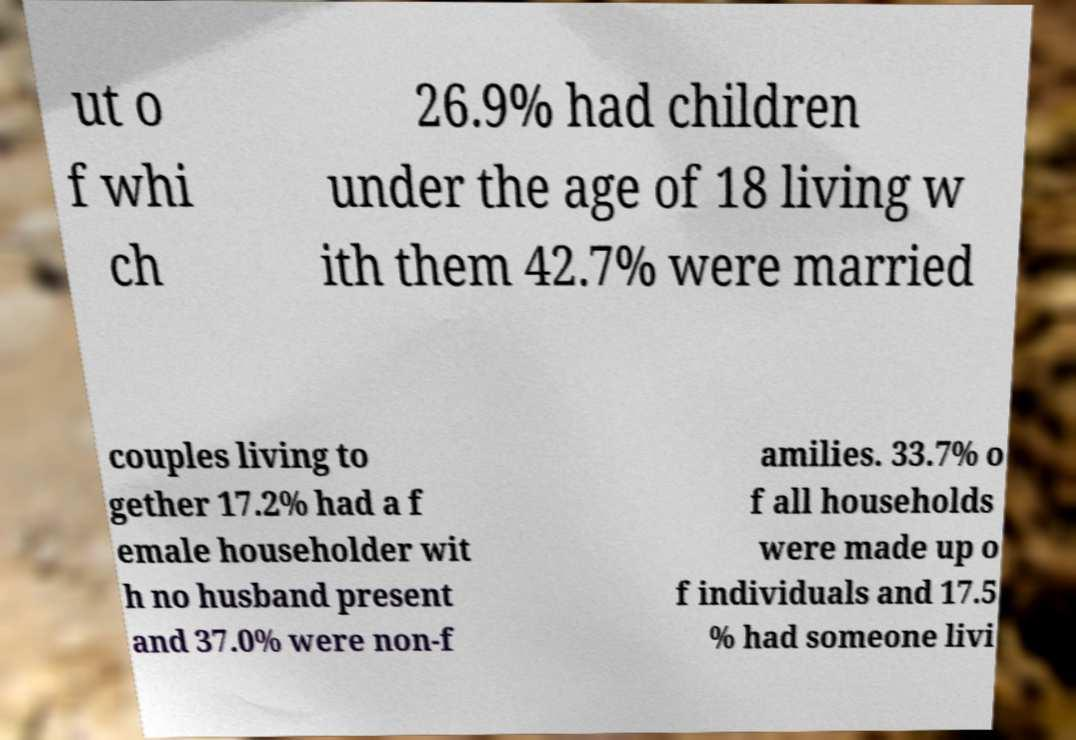Please read and relay the text visible in this image. What does it say? ut o f whi ch 26.9% had children under the age of 18 living w ith them 42.7% were married couples living to gether 17.2% had a f emale householder wit h no husband present and 37.0% were non-f amilies. 33.7% o f all households were made up o f individuals and 17.5 % had someone livi 